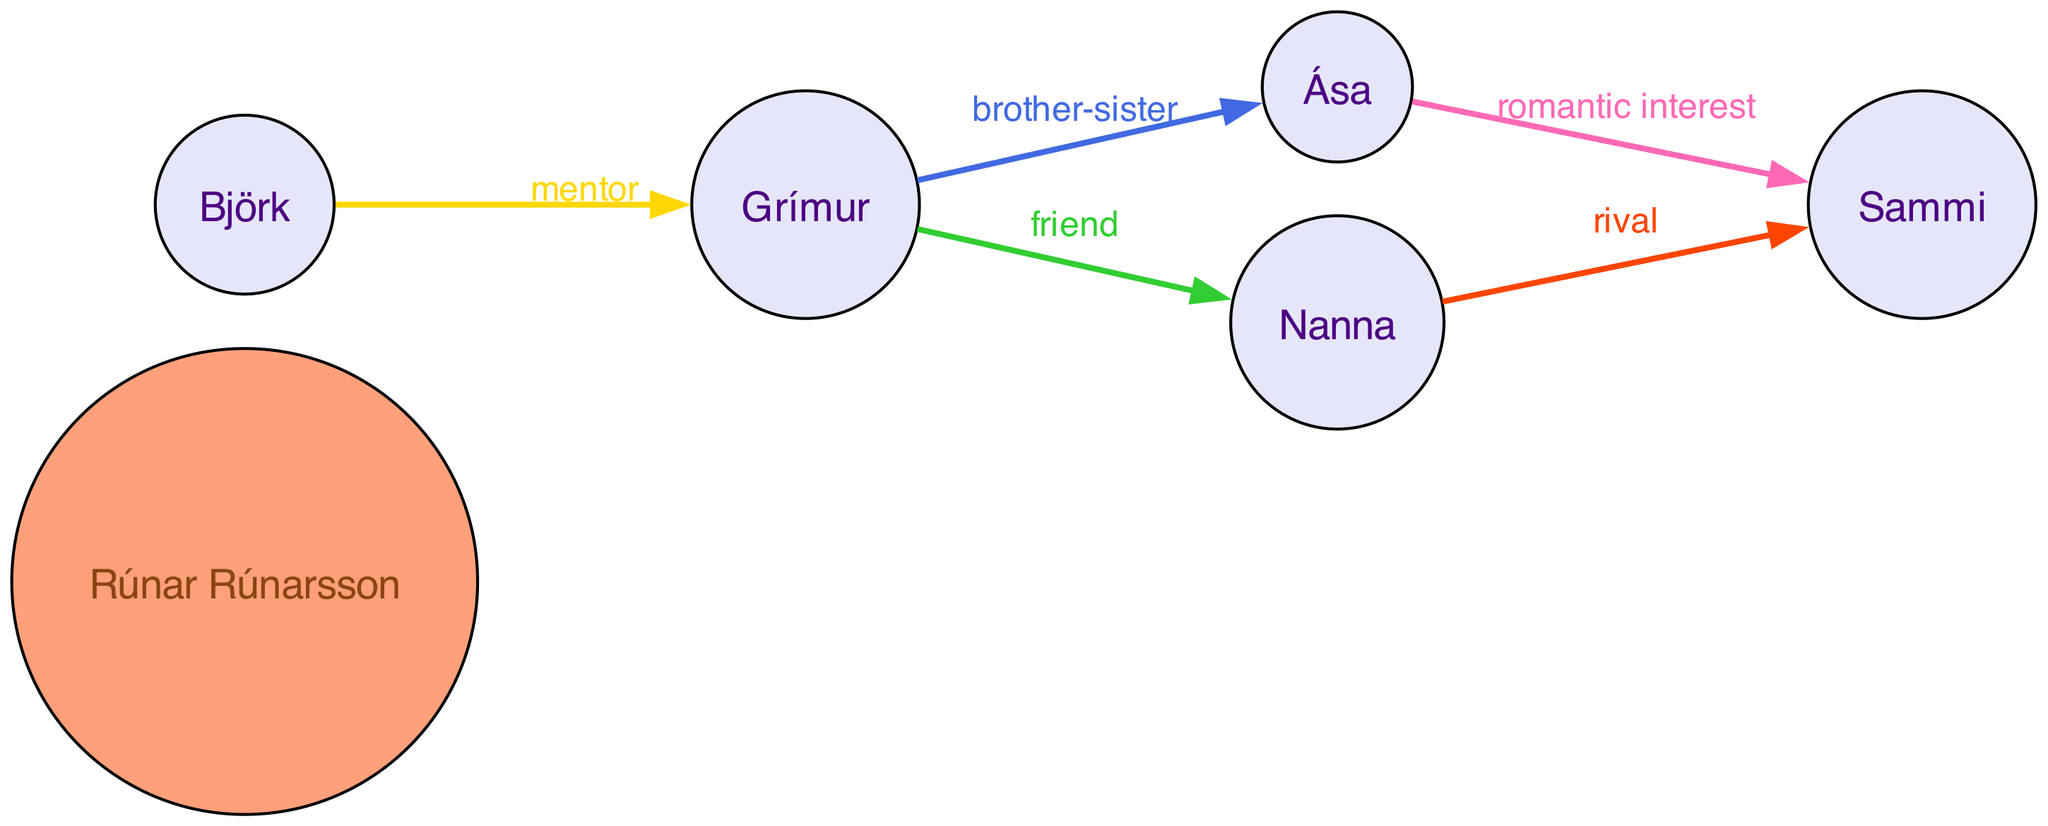What is the total number of nodes in the diagram? The diagram contains a list of nodes which are the characters featured. Counting them, we find 6 nodes: Rúnar Rúnarsson, Grímur, Ása, Björk, Nanna, and Sammi.
Answer: 6 What relationship does Grímur have with Ása? In the diagram, Grímur has a directed edge leading to Ása with the relationship labeled as "brother-sister." This indicates a sibling relationship between the two characters.
Answer: brother-sister Who is the mentor of Grímur? The diagram shows a directed edge from Björk to Grímur, labeled as "mentor." Therefore, Björk is the mentor of Grímur, guiding or teaching him in some capacity.
Answer: Björk What type of relationship exists between Sammi and Ása? In the diagram, there is no direct edge or relationship between Sammi and Ása. This means their relationship is not specified or potentially non-existent in the context shown.
Answer: None How many edges are present in the diagram? Each relationship is represented by an edge in the directed graph. By counting the relationships listed, we see there are 5 distinct edges: brother-sister, friend, mentor, romantic interest, and rival.
Answer: 5 Which character is a romantic interest to Ása? The directed edge from Ása to Sammi is marked as "romantic interest." This indicates Sammi's role as a romantic partner or interest for Ása within the narrative context.
Answer: Sammi Who is the rival of Sammi? The diagram indicates a rivalry from Nanna to Sammi with the relationship labeled "rival." Nanna competes with or opposes Sammi in some manner.
Answer: Nanna What is the nature of the relationship between Grímur and Nanna? In the diagram, there is no direct edge or relationship specified between Grímur and Nanna, indicating that their relationship isn’t defined in this particular depiction.
Answer: None 